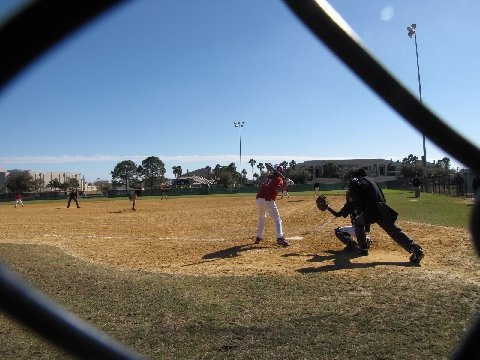Describe the objects in this image and their specific colors. I can see people in blue, black, gray, and tan tones, people in blue, black, gray, and maroon tones, people in blue, black, gray, and darkgreen tones, baseball glove in blue, black, gray, and maroon tones, and people in blue, black, maroon, and gray tones in this image. 